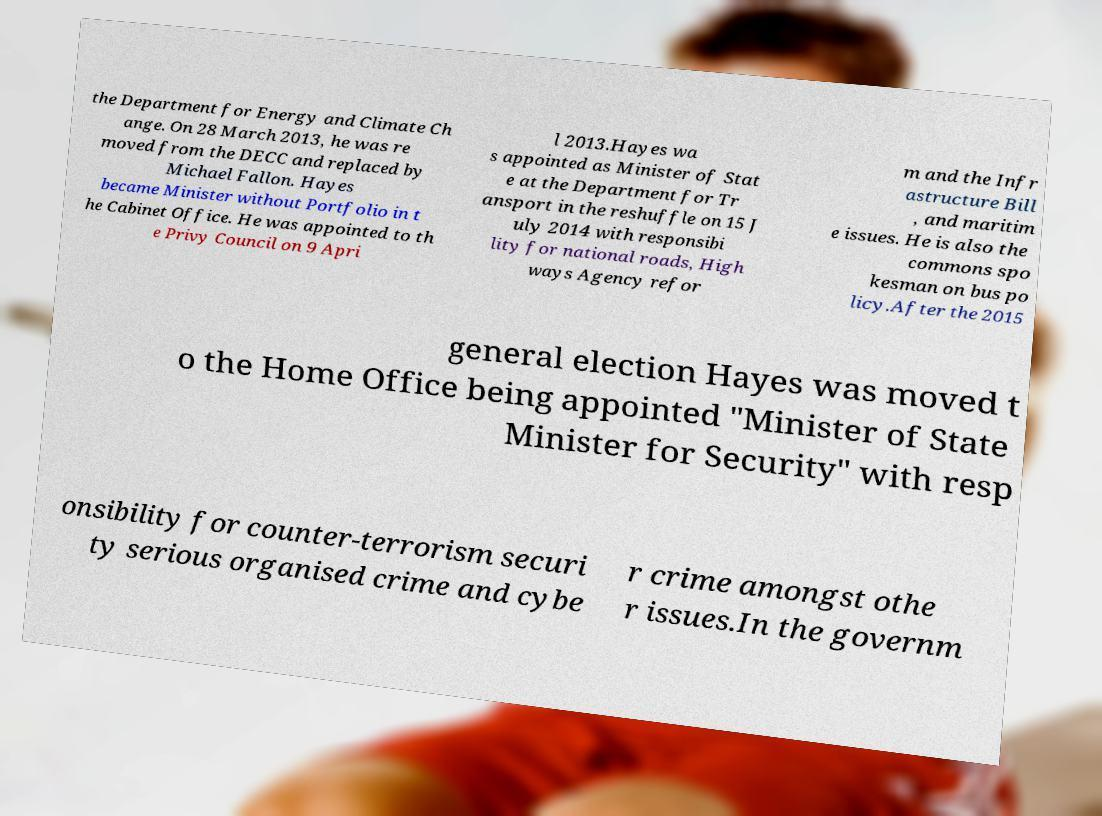Please read and relay the text visible in this image. What does it say? the Department for Energy and Climate Ch ange. On 28 March 2013, he was re moved from the DECC and replaced by Michael Fallon. Hayes became Minister without Portfolio in t he Cabinet Office. He was appointed to th e Privy Council on 9 Apri l 2013.Hayes wa s appointed as Minister of Stat e at the Department for Tr ansport in the reshuffle on 15 J uly 2014 with responsibi lity for national roads, High ways Agency refor m and the Infr astructure Bill , and maritim e issues. He is also the commons spo kesman on bus po licy.After the 2015 general election Hayes was moved t o the Home Office being appointed "Minister of State Minister for Security" with resp onsibility for counter-terrorism securi ty serious organised crime and cybe r crime amongst othe r issues.In the governm 